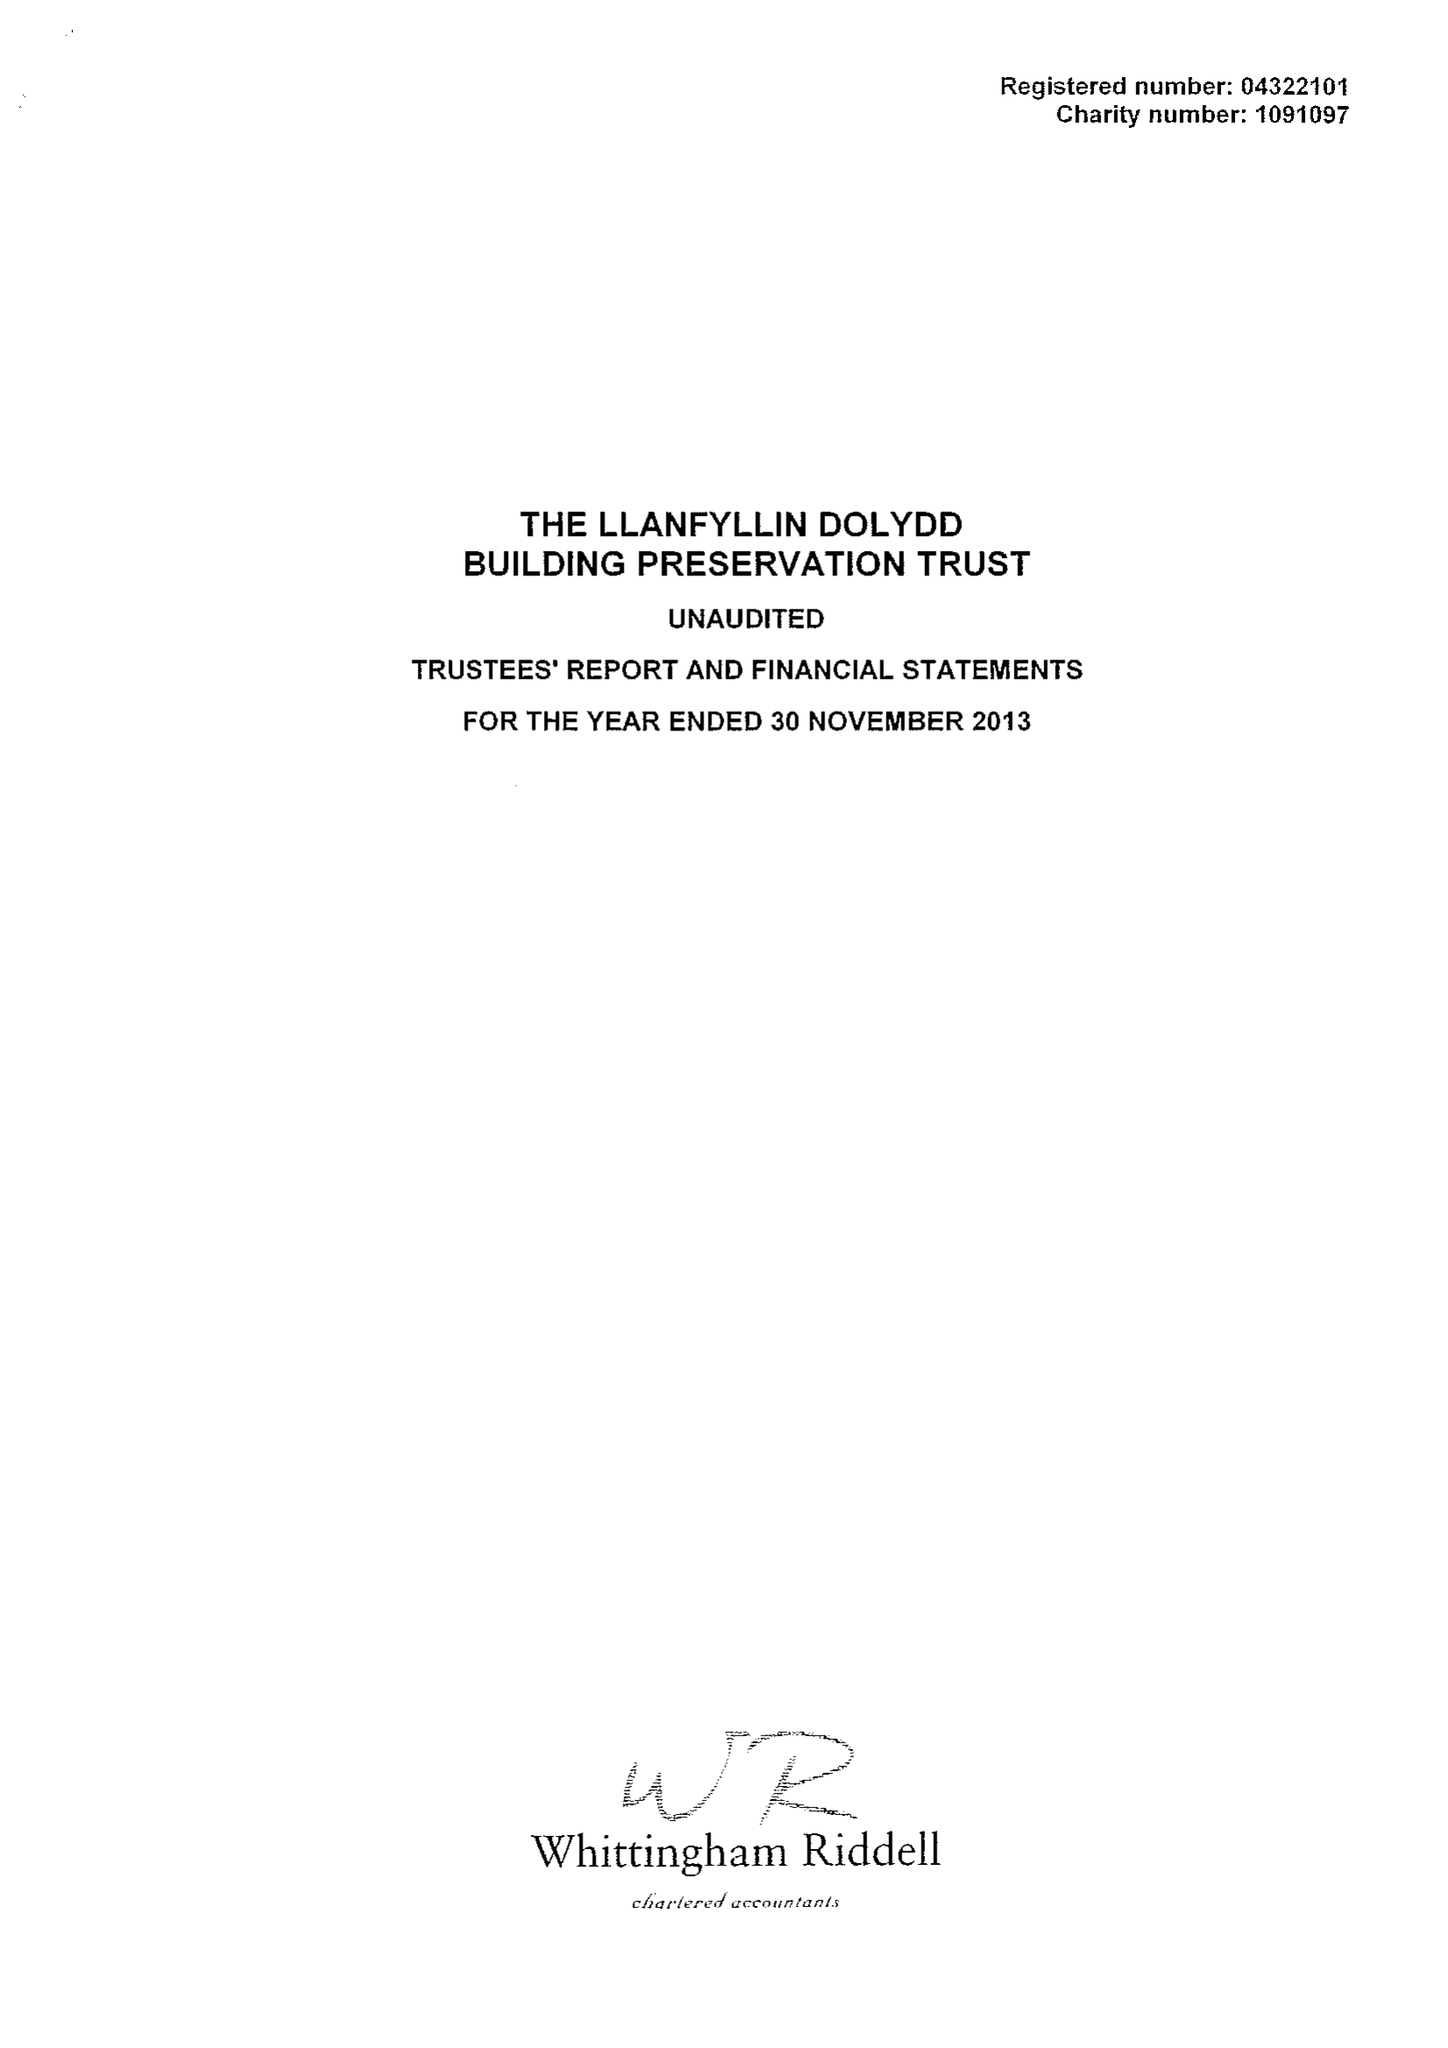What is the value for the charity_number?
Answer the question using a single word or phrase. 1091097 